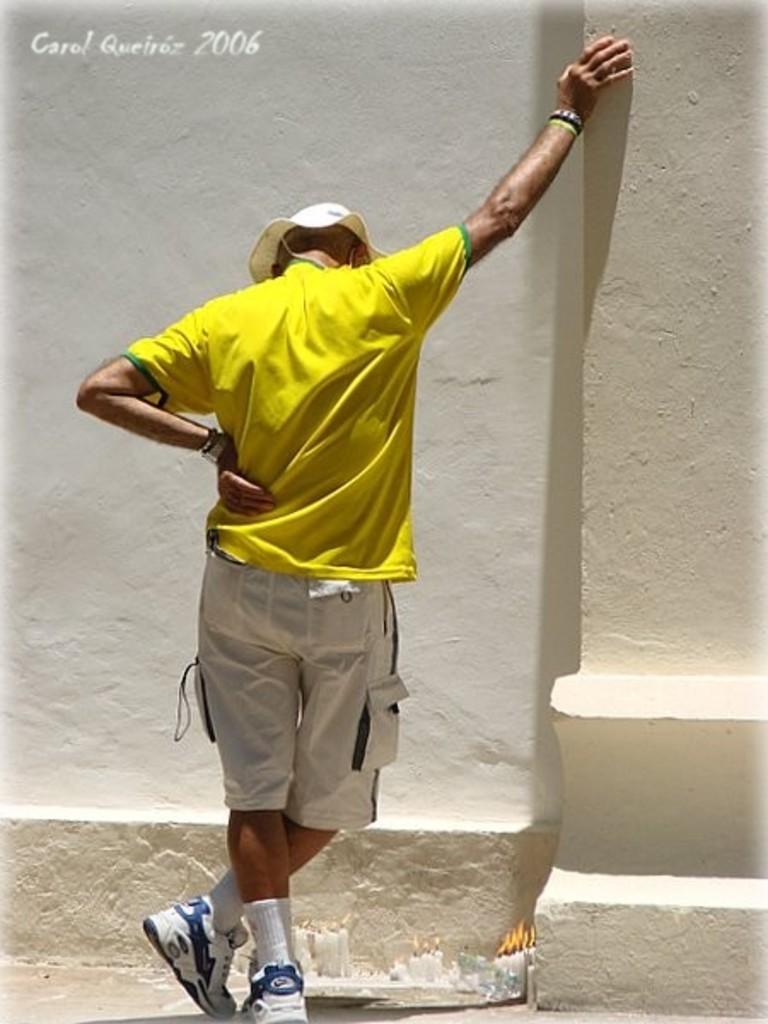How would you summarize this image in a sentence or two? In the top right corner of the picture we can see there is something written. In this picture we can see the wall and a pillar. We can see a man wearing yellow t-shirt and a hat. He kept his hand on a pillar. At the bottom portion of the picture we can see the burning candles. 